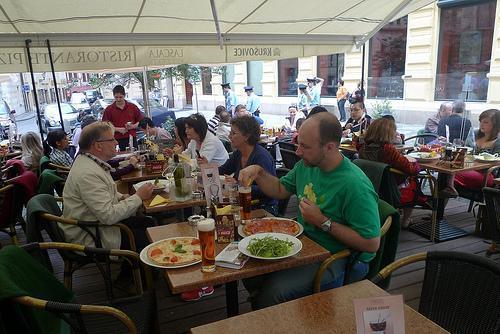How many green shirts?
Give a very brief answer. 1. 